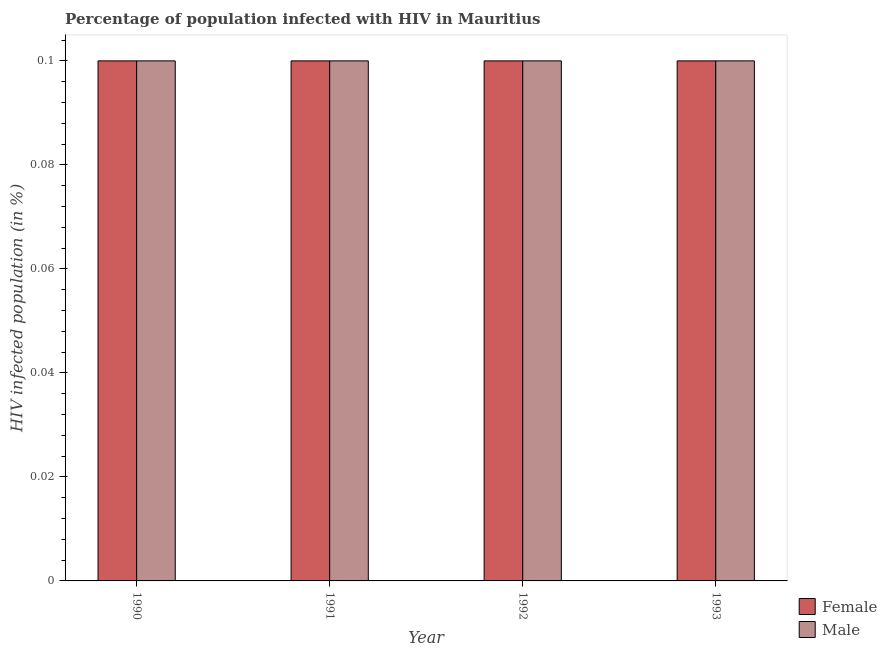How many different coloured bars are there?
Keep it short and to the point. 2. How many bars are there on the 3rd tick from the left?
Provide a short and direct response. 2. How many bars are there on the 1st tick from the right?
Ensure brevity in your answer.  2. What is the percentage of females who are infected with hiv in 1991?
Your answer should be very brief. 0.1. Across all years, what is the maximum percentage of males who are infected with hiv?
Offer a terse response. 0.1. Across all years, what is the minimum percentage of females who are infected with hiv?
Keep it short and to the point. 0.1. What is the total percentage of females who are infected with hiv in the graph?
Your response must be concise. 0.4. In the year 1992, what is the difference between the percentage of females who are infected with hiv and percentage of males who are infected with hiv?
Your answer should be compact. 0. In how many years, is the percentage of females who are infected with hiv greater than 0.016 %?
Offer a terse response. 4. Is the difference between the percentage of females who are infected with hiv in 1990 and 1992 greater than the difference between the percentage of males who are infected with hiv in 1990 and 1992?
Offer a very short reply. No. What is the difference between the highest and the second highest percentage of males who are infected with hiv?
Give a very brief answer. 0. Is the sum of the percentage of males who are infected with hiv in 1992 and 1993 greater than the maximum percentage of females who are infected with hiv across all years?
Ensure brevity in your answer.  Yes. What does the 2nd bar from the left in 1993 represents?
Make the answer very short. Male. What does the 2nd bar from the right in 1990 represents?
Keep it short and to the point. Female. How many bars are there?
Give a very brief answer. 8. Are all the bars in the graph horizontal?
Ensure brevity in your answer.  No. How many years are there in the graph?
Provide a succinct answer. 4. What is the difference between two consecutive major ticks on the Y-axis?
Offer a very short reply. 0.02. Does the graph contain grids?
Your response must be concise. No. How are the legend labels stacked?
Provide a short and direct response. Vertical. What is the title of the graph?
Give a very brief answer. Percentage of population infected with HIV in Mauritius. Does "Banks" appear as one of the legend labels in the graph?
Your response must be concise. No. What is the label or title of the X-axis?
Make the answer very short. Year. What is the label or title of the Y-axis?
Your response must be concise. HIV infected population (in %). What is the HIV infected population (in %) in Female in 1991?
Offer a very short reply. 0.1. What is the HIV infected population (in %) in Female in 1992?
Your response must be concise. 0.1. What is the HIV infected population (in %) of Male in 1993?
Your answer should be compact. 0.1. Across all years, what is the minimum HIV infected population (in %) in Female?
Keep it short and to the point. 0.1. Across all years, what is the minimum HIV infected population (in %) of Male?
Provide a succinct answer. 0.1. What is the total HIV infected population (in %) of Female in the graph?
Offer a terse response. 0.4. What is the total HIV infected population (in %) in Male in the graph?
Your answer should be compact. 0.4. What is the difference between the HIV infected population (in %) in Female in 1990 and that in 1991?
Offer a terse response. 0. What is the difference between the HIV infected population (in %) in Female in 1990 and that in 1992?
Provide a succinct answer. 0. What is the difference between the HIV infected population (in %) of Female in 1990 and that in 1993?
Ensure brevity in your answer.  0. What is the difference between the HIV infected population (in %) in Female in 1991 and that in 1993?
Keep it short and to the point. 0. What is the difference between the HIV infected population (in %) in Female in 1992 and that in 1993?
Offer a terse response. 0. What is the difference between the HIV infected population (in %) in Female in 1991 and the HIV infected population (in %) in Male in 1992?
Give a very brief answer. 0. What is the difference between the HIV infected population (in %) of Female in 1992 and the HIV infected population (in %) of Male in 1993?
Keep it short and to the point. 0. What is the average HIV infected population (in %) in Female per year?
Keep it short and to the point. 0.1. What is the average HIV infected population (in %) of Male per year?
Keep it short and to the point. 0.1. In the year 1991, what is the difference between the HIV infected population (in %) in Female and HIV infected population (in %) in Male?
Your response must be concise. 0. In the year 1993, what is the difference between the HIV infected population (in %) in Female and HIV infected population (in %) in Male?
Your answer should be compact. 0. What is the ratio of the HIV infected population (in %) of Female in 1990 to that in 1991?
Keep it short and to the point. 1. What is the ratio of the HIV infected population (in %) in Male in 1990 to that in 1991?
Keep it short and to the point. 1. What is the ratio of the HIV infected population (in %) of Female in 1990 to that in 1992?
Keep it short and to the point. 1. What is the ratio of the HIV infected population (in %) of Female in 1991 to that in 1992?
Keep it short and to the point. 1. What is the ratio of the HIV infected population (in %) in Female in 1991 to that in 1993?
Make the answer very short. 1. What is the ratio of the HIV infected population (in %) in Male in 1991 to that in 1993?
Make the answer very short. 1. What is the difference between the highest and the second highest HIV infected population (in %) of Female?
Make the answer very short. 0. What is the difference between the highest and the second highest HIV infected population (in %) of Male?
Your response must be concise. 0. 